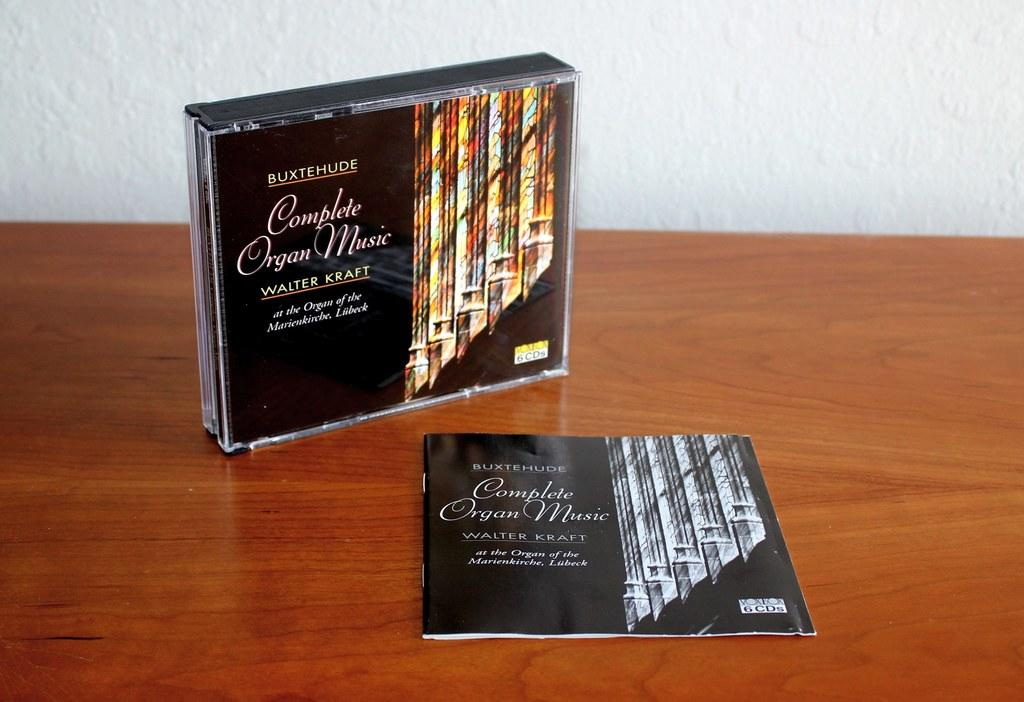<image>
Present a compact description of the photo's key features. A cd case for Walter Kraft's Complete Organ Music on a table with the insert booklet next to it. 